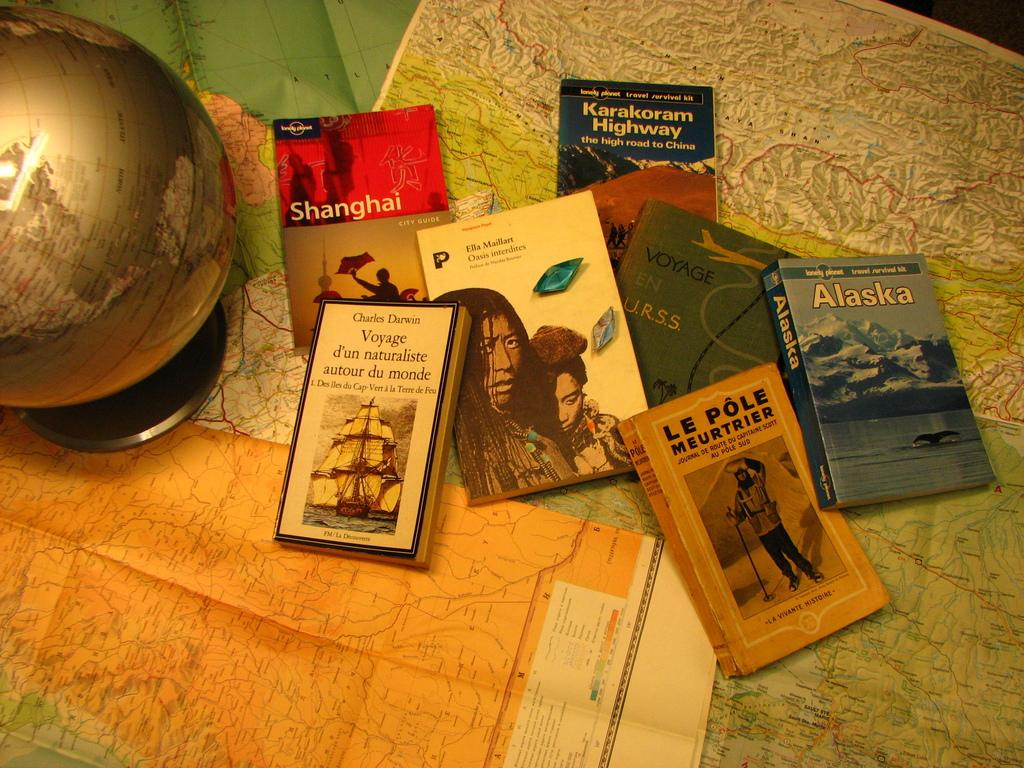<image>
Summarize the visual content of the image. A pile of books, including two with Alaska and Shanghai in the titles, are scattered on the table 